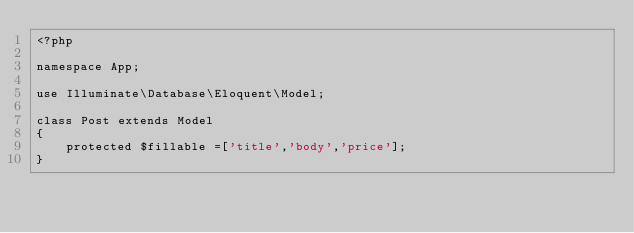<code> <loc_0><loc_0><loc_500><loc_500><_PHP_><?php

namespace App;

use Illuminate\Database\Eloquent\Model;

class Post extends Model
{
    protected $fillable =['title','body','price'];
}
</code> 